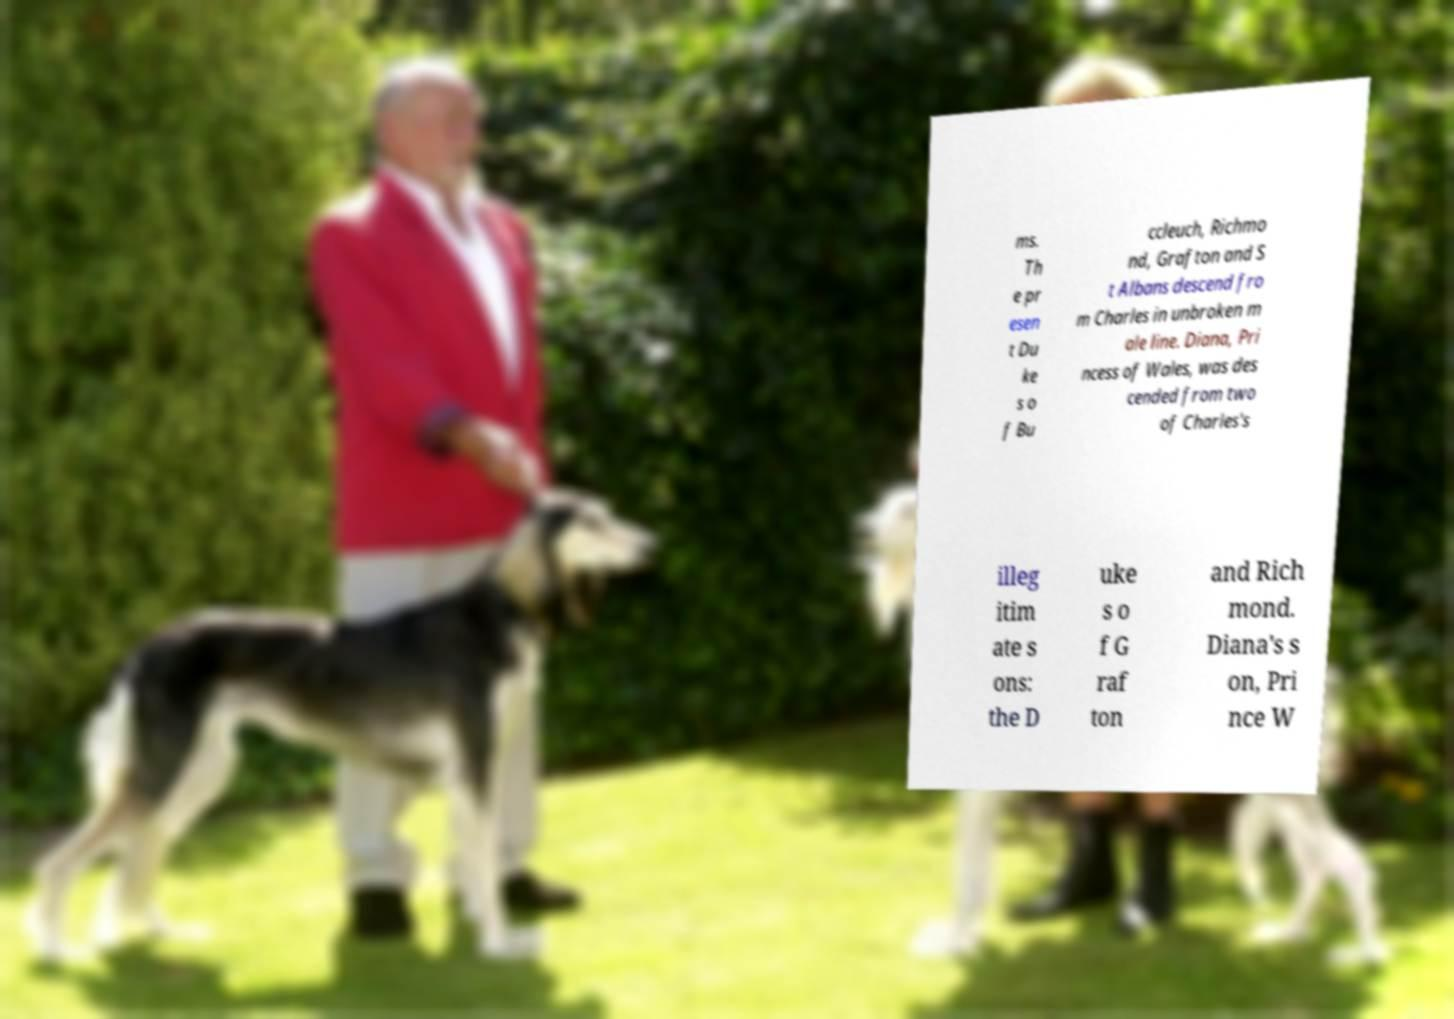Please identify and transcribe the text found in this image. ms. Th e pr esen t Du ke s o f Bu ccleuch, Richmo nd, Grafton and S t Albans descend fro m Charles in unbroken m ale line. Diana, Pri ncess of Wales, was des cended from two of Charles's illeg itim ate s ons: the D uke s o f G raf ton and Rich mond. Diana's s on, Pri nce W 